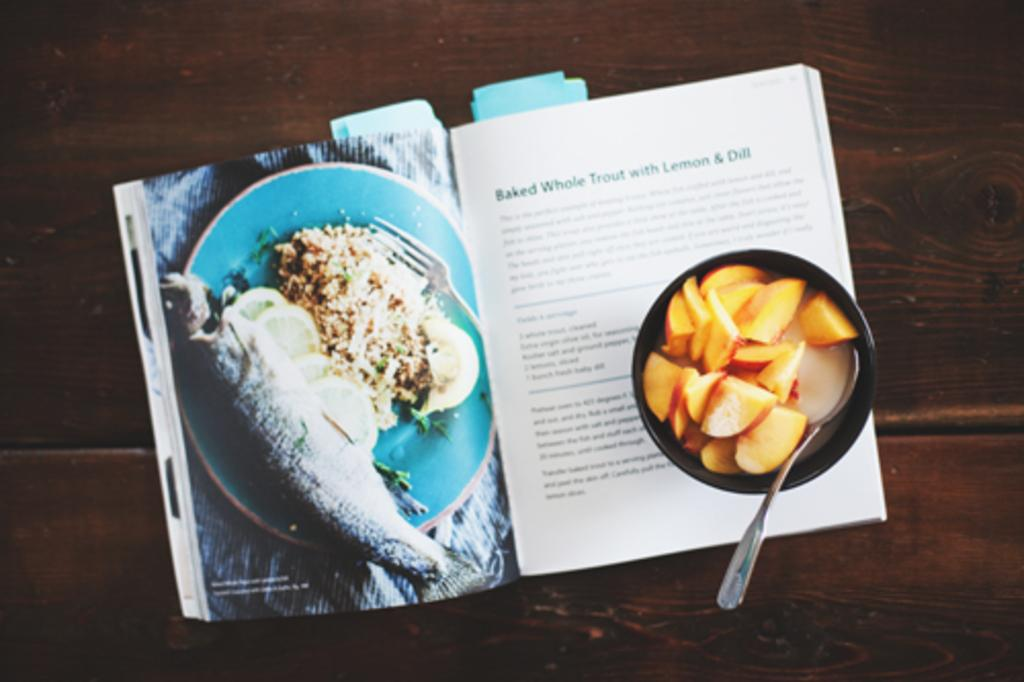Provide a one-sentence caption for the provided image. An open cookbook on a page with a recipe on Baked Whole Trout with Lemon & Dill. 